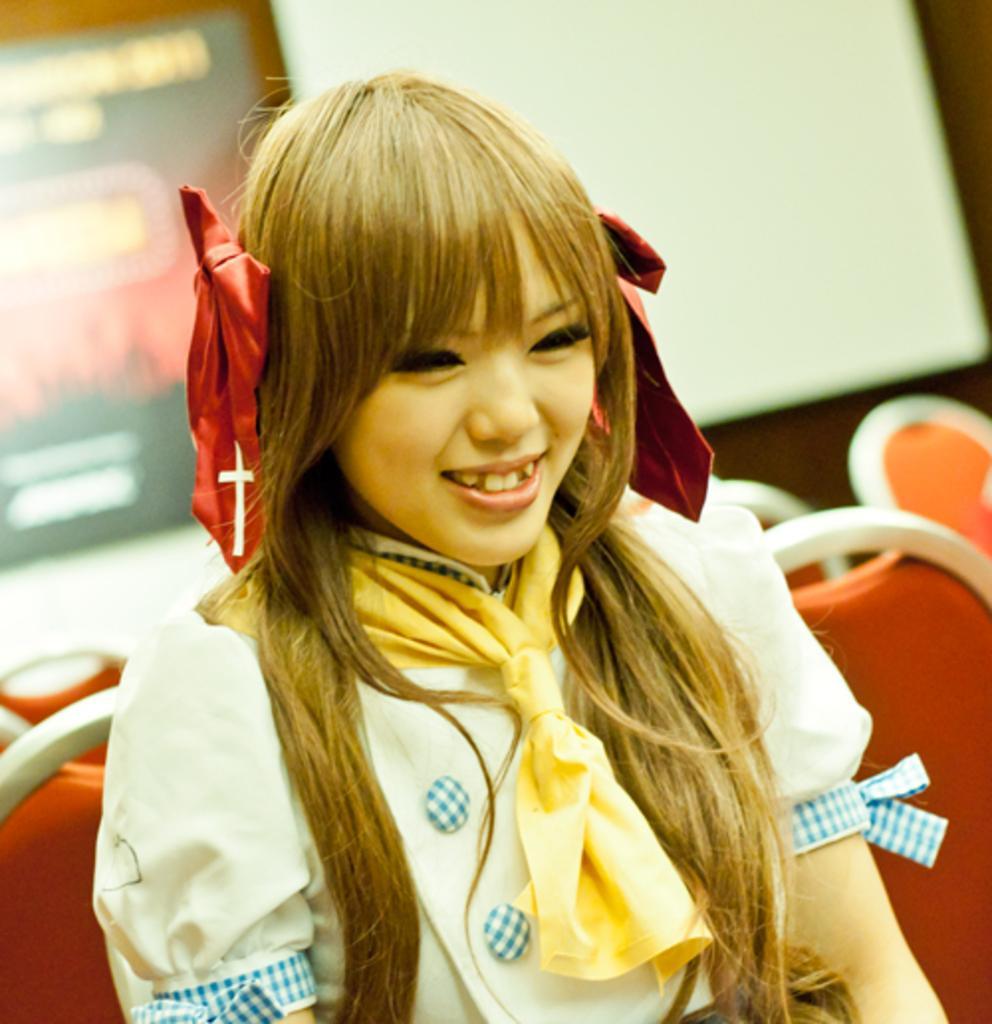Describe this image in one or two sentences. In this picture we can see a woman, she is smiling, and she is seated on the chair. 